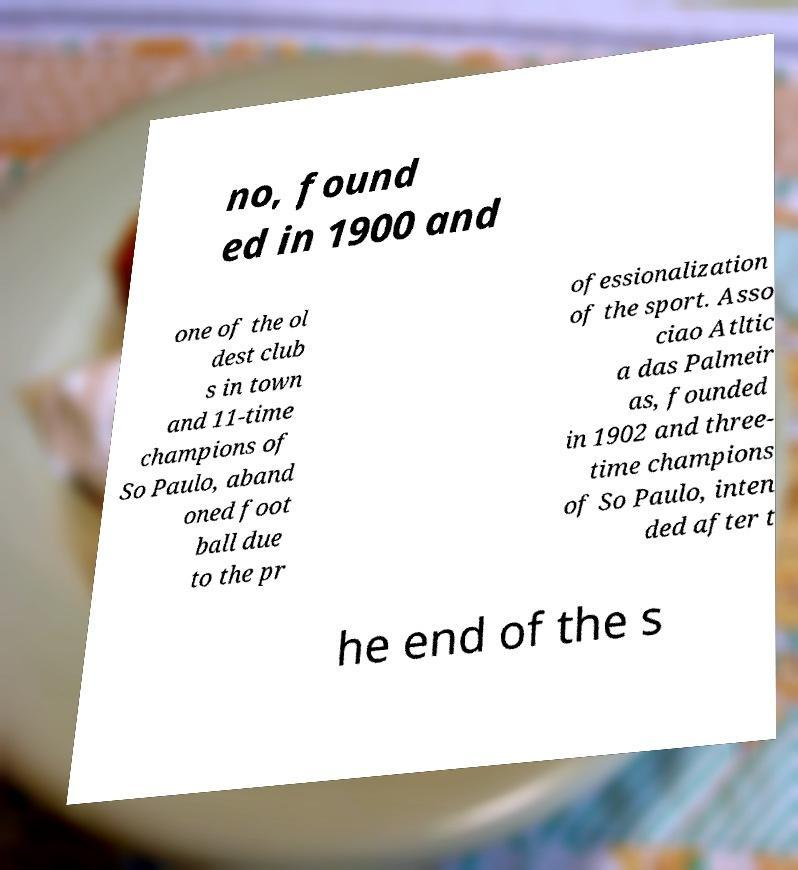Can you accurately transcribe the text from the provided image for me? no, found ed in 1900 and one of the ol dest club s in town and 11-time champions of So Paulo, aband oned foot ball due to the pr ofessionalization of the sport. Asso ciao Atltic a das Palmeir as, founded in 1902 and three- time champions of So Paulo, inten ded after t he end of the s 